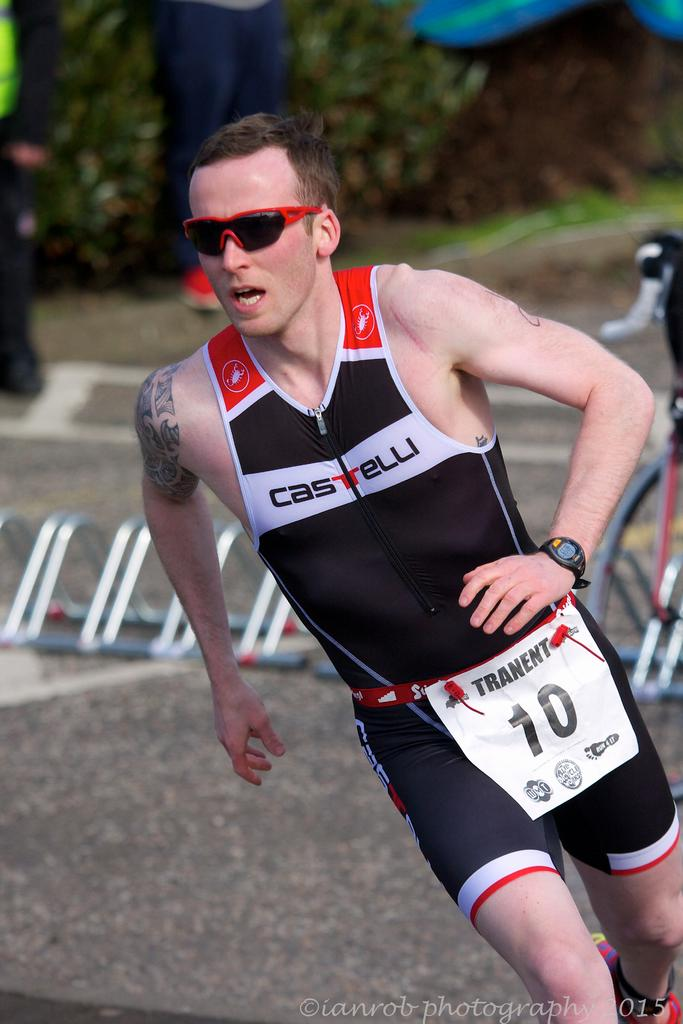<image>
Write a terse but informative summary of the picture. A man wearing a Castelli track suit runs down the road. 